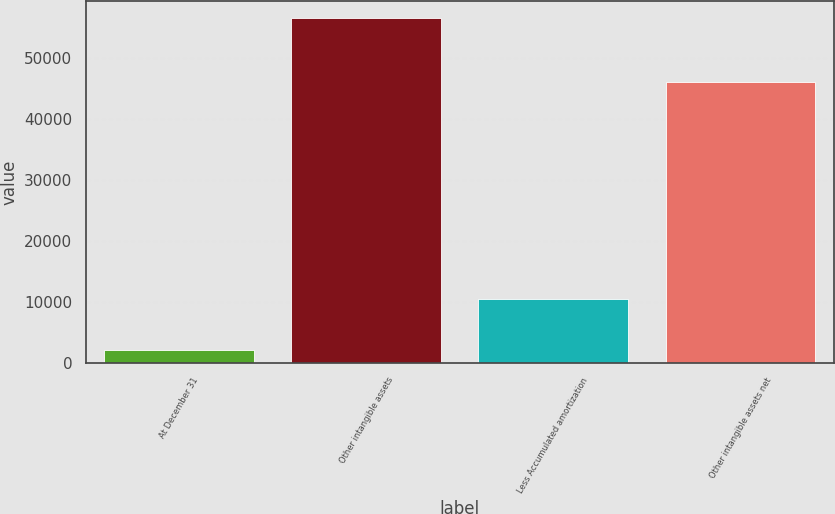Convert chart. <chart><loc_0><loc_0><loc_500><loc_500><bar_chart><fcel>At December 31<fcel>Other intangible assets<fcel>Less Accumulated amortization<fcel>Other intangible assets net<nl><fcel>2015<fcel>56491<fcel>10375<fcel>46116<nl></chart> 